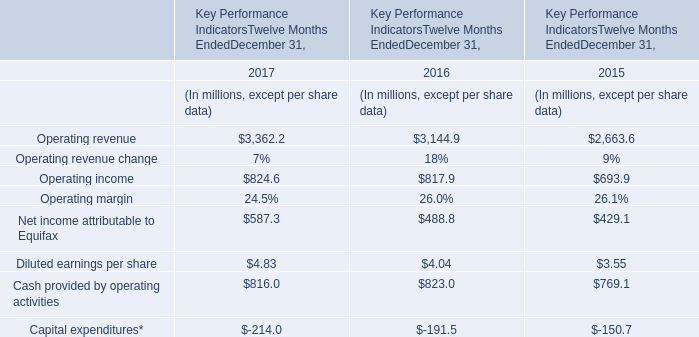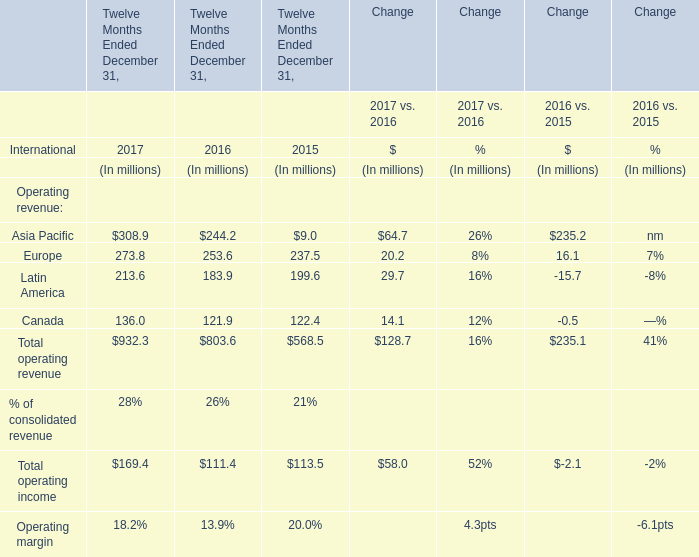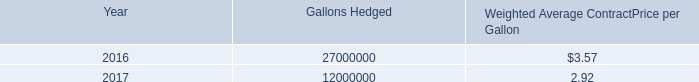what is the percentage growth of the aggregate fair values of our outstanding fuel hedge for 2014 to 2015 
Computations: ((37.8 - 34.4) / 34.4)
Answer: 0.09884. 